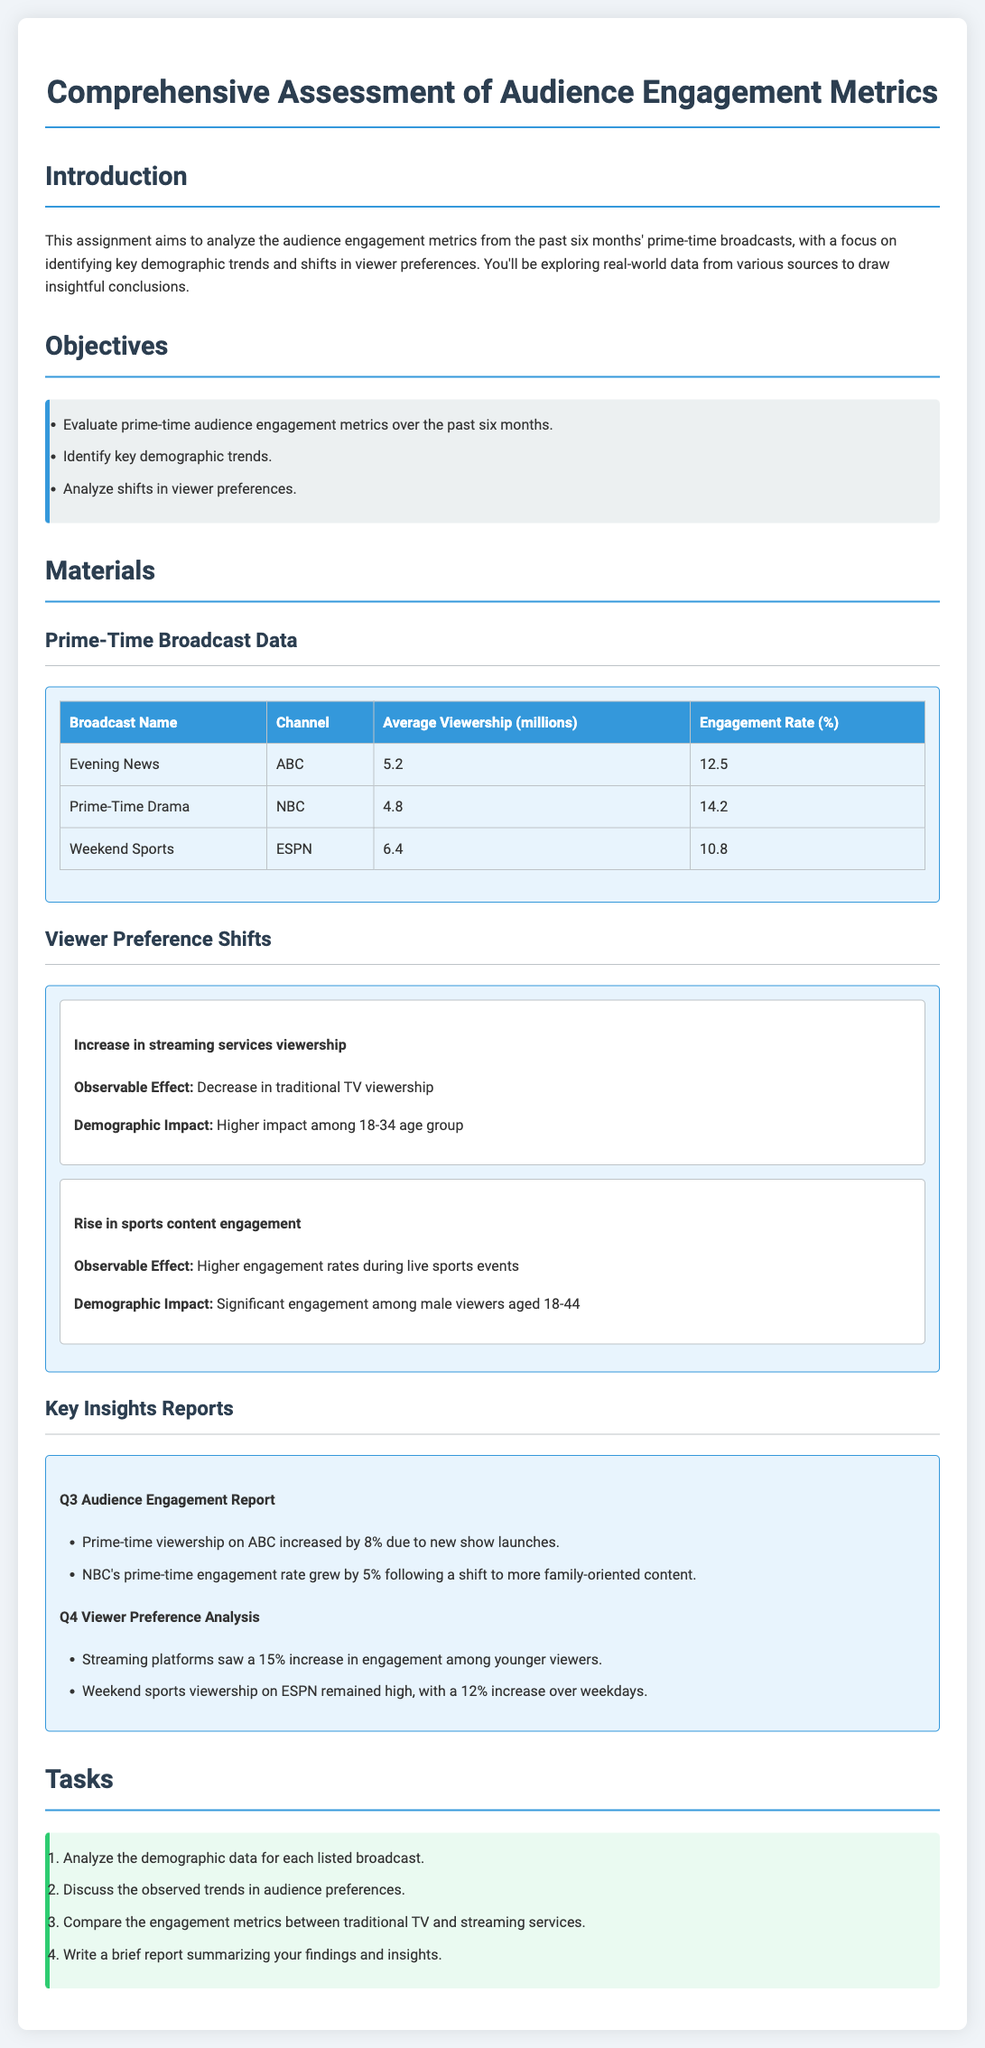What is the average viewership of the Evening News? The average viewership of the Evening News is listed in the table as 5.2 million.
Answer: 5.2 million Which channel broadcasts the Prime-Time Drama? The channel for the Prime-Time Drama can be found in the table, showing it is NBC.
Answer: NBC What was the percentage increase in prime-time viewership on ABC in Q3? The Q3 Audience Engagement Report states an 8% increase in ABC's prime-time viewership.
Answer: 8% Which age group experienced the highest impact from the increase in streaming services viewership? The document mentions that the higher impact was among the 18-34 age group.
Answer: 18-34 age group What engagement rate did the Weekend Sports broadcast have? The engagement rate for Weekend Sports is provided in the table as 10.8%.
Answer: 10.8% What observable effect is associated with the rise in sports content engagement? The document states the observable effect is higher engagement rates during live sports events.
Answer: Higher engagement rates during live sports events How much did NBC's prime-time engagement rate grow by in Q3? The document indicates that NBC's engagement rate grew by 5% in Q3.
Answer: 5% What demographic has significant engagement during live sports events? The document identifies that significant engagement is among male viewers aged 18-44.
Answer: Male viewers aged 18-44 